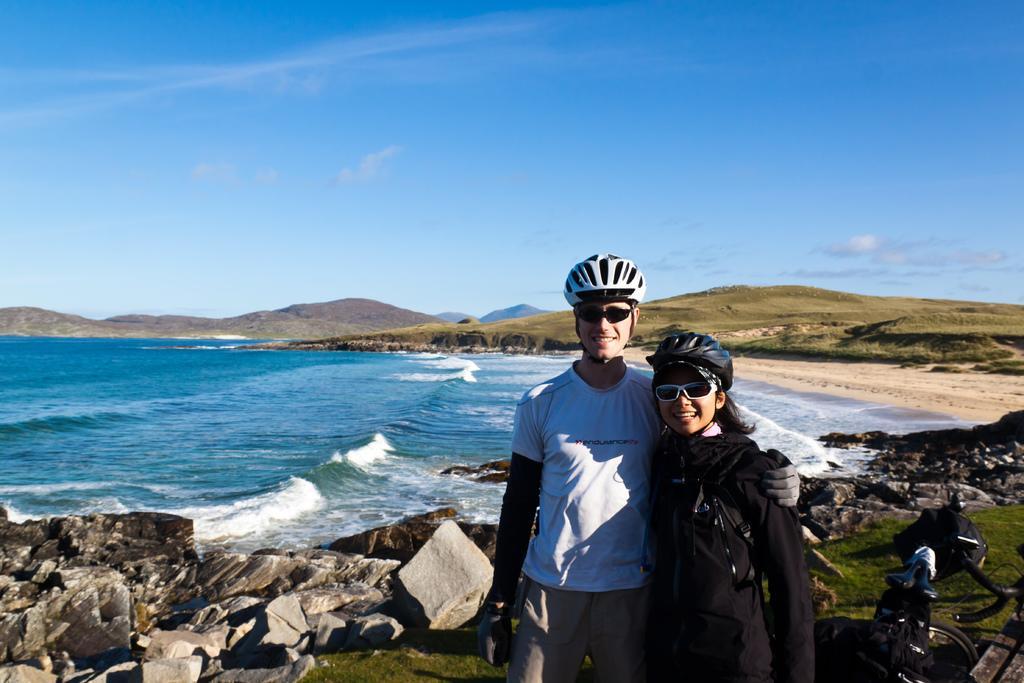Could you give a brief overview of what you see in this image? In the picture I can a man and a woman are standing together and smiling. These people are wearing helmets and shades. In the background I can see rocks, the water, hills and the sky. On the right side of the image I can see a bicycle and some other objects. 